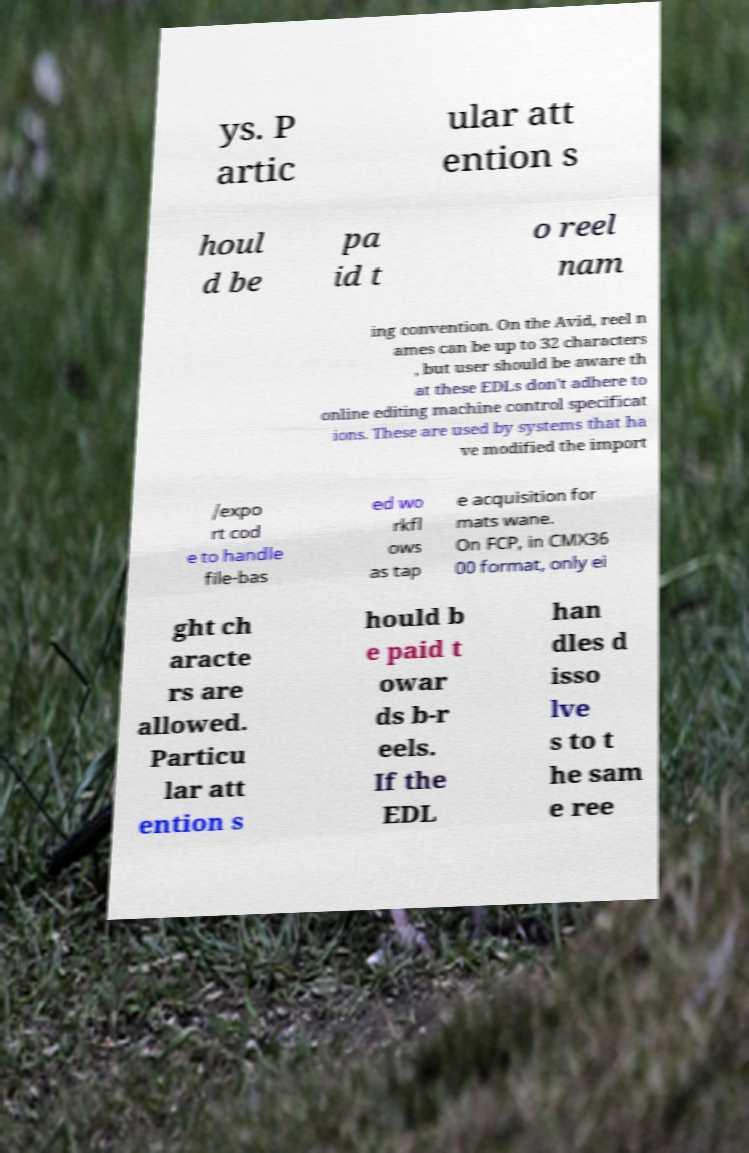For documentation purposes, I need the text within this image transcribed. Could you provide that? ys. P artic ular att ention s houl d be pa id t o reel nam ing convention. On the Avid, reel n ames can be up to 32 characters , but user should be aware th at these EDLs don't adhere to online editing machine control specificat ions. These are used by systems that ha ve modified the import /expo rt cod e to handle file-bas ed wo rkfl ows as tap e acquisition for mats wane. On FCP, in CMX36 00 format, only ei ght ch aracte rs are allowed. Particu lar att ention s hould b e paid t owar ds b-r eels. If the EDL han dles d isso lve s to t he sam e ree 